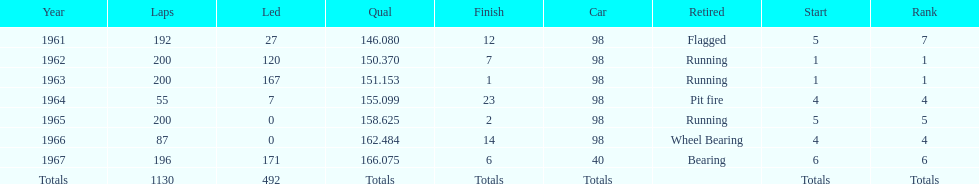How many total laps have been driven in the indy 500? 1130. 